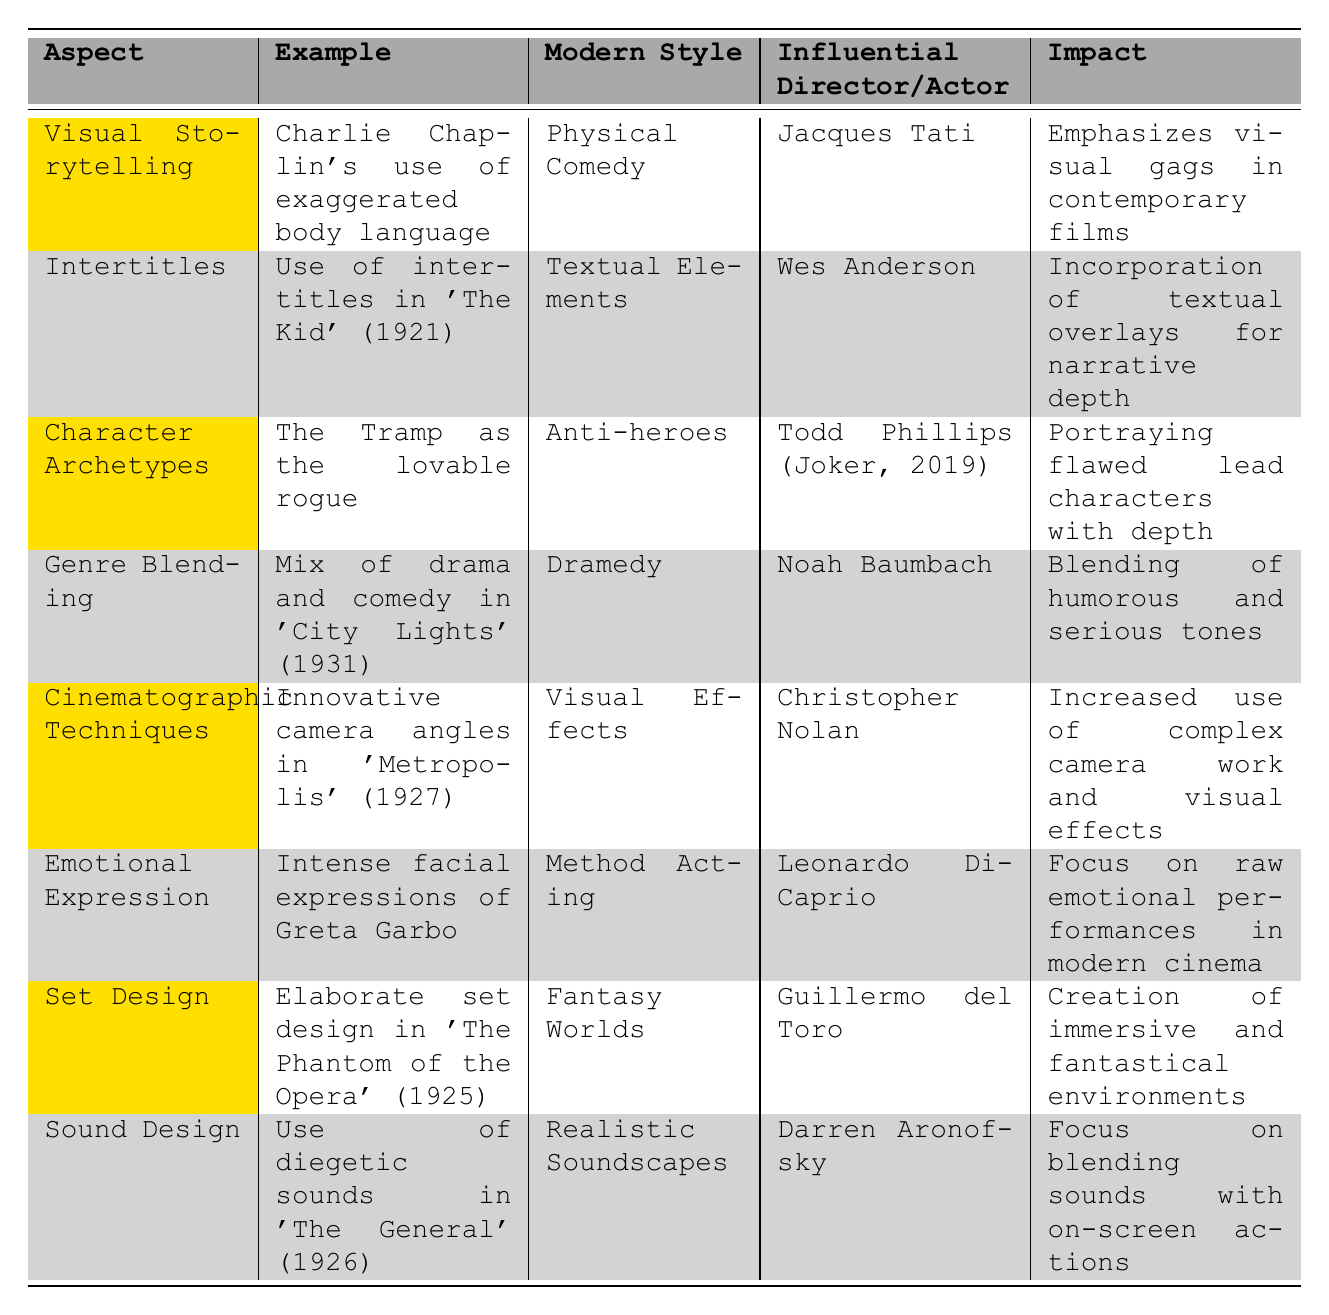What modern style is associated with Charlie Chaplin's use of exaggerated body language? The table indicates that Charlie Chaplin's visual storytelling through exaggerated body language relates to the modern style of Physical Comedy.
Answer: Physical Comedy Which influential director is noted for incorporating textual overlays for narrative depth? The table states that Wes Anderson is associated with the modern style of Textual Elements and is noted for incorporating textual overlays for narrative depth.
Answer: Wes Anderson Is the character archetype of the Tramp related to anti-heroes in modern cinema? The table confirms that the Tramp, as the lovable rogue, is indeed related to the modern style of Anti-heroes.
Answer: Yes How many modern styles mentioned involve blending elements from different genres? By reviewing the table, we can see that Genre Blending relates to the modern style of Dramedy. The only other mention of blending genres discusses the incorporation of humorous and serious tones related to the same style. Thus, only one modern style involves genre blending.
Answer: 1 Which modern director is influenced by the emotional expressions seen in Greta Garbo's performances? According to the table, Leonardo DiCaprio is noted as the influential actor connected to Method Acting, which emphasizes intense emotional expression akin to Greta Garbo's performances.
Answer: Leonardo DiCaprio What impact is associated with the cinematic techniques in 'Metropolis'? The table states that the impact of innovative camera angles in 'Metropolis' results in an increased use of complex camera work and visual effects in modern cinema.
Answer: Increased use of complex camera work and visual effects Are there any styles that focus on creating immersive fantasy worlds? Yes, the table shows that elaborate set design in 'The Phantom of the Opera' relates to the modern style of Fantasy Worlds.
Answer: Yes Which example showcases the use of diegetic sounds? The table indicates that 'The General' (1926) is an example of the use of diegetic sounds, which is linked to realistic soundscapes in modern cinema.
Answer: The General (1926) What is the common impact of sound design techniques across modern cinema? By examining the table, we observe that the impact of sound design emphasizes blending sounds with on-screen actions, leading to a focus on realistic soundscapes.
Answer: Focus on blending sounds with on-screen actions 